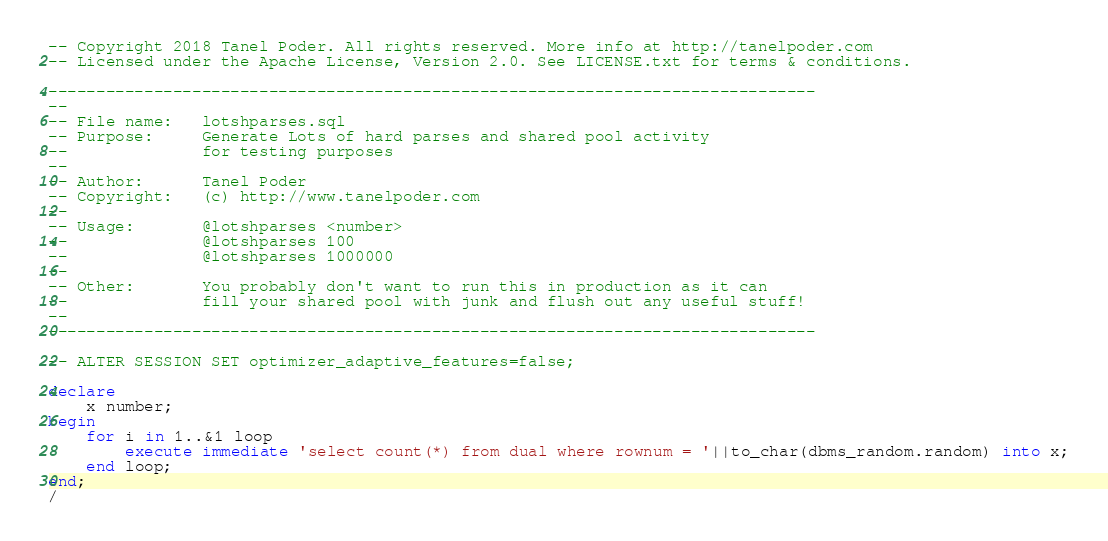Convert code to text. <code><loc_0><loc_0><loc_500><loc_500><_SQL_>-- Copyright 2018 Tanel Poder. All rights reserved. More info at http://tanelpoder.com
-- Licensed under the Apache License, Version 2.0. See LICENSE.txt for terms & conditions.

--------------------------------------------------------------------------------
--
-- File name:   lotshparses.sql
-- Purpose:     Generate Lots of hard parses and shared pool activity 
--              for testing purposes
--
-- Author:      Tanel Poder
-- Copyright:   (c) http://www.tanelpoder.com
--              
-- Usage:       @lotshparses <number>
--              @lotshparses 100
--              @lotshparses 1000000
--	        
-- Other:       You probably don't want to run this in production as it can
--              fill your shared pool with junk and flush out any useful stuff!
--
--------------------------------------------------------------------------------

-- ALTER SESSION SET optimizer_adaptive_features=false;

declare
    x number;
begin
    for i in 1..&1 loop
    	execute immediate 'select count(*) from dual where rownum = '||to_char(dbms_random.random) into x;
    end loop;
end;
/
</code> 